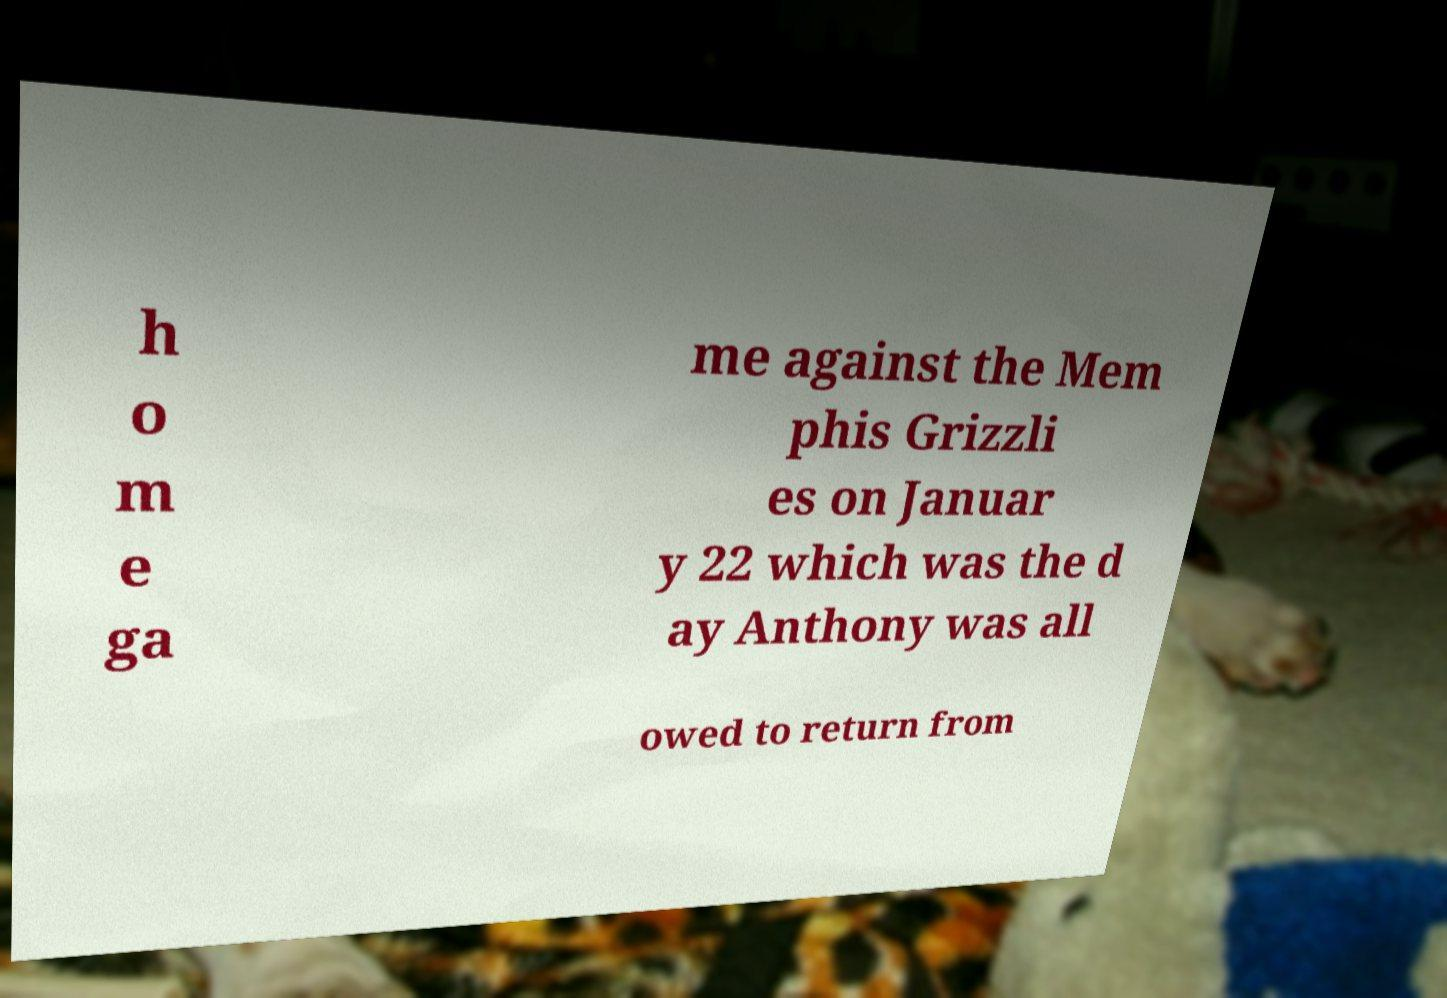Please identify and transcribe the text found in this image. h o m e ga me against the Mem phis Grizzli es on Januar y 22 which was the d ay Anthony was all owed to return from 